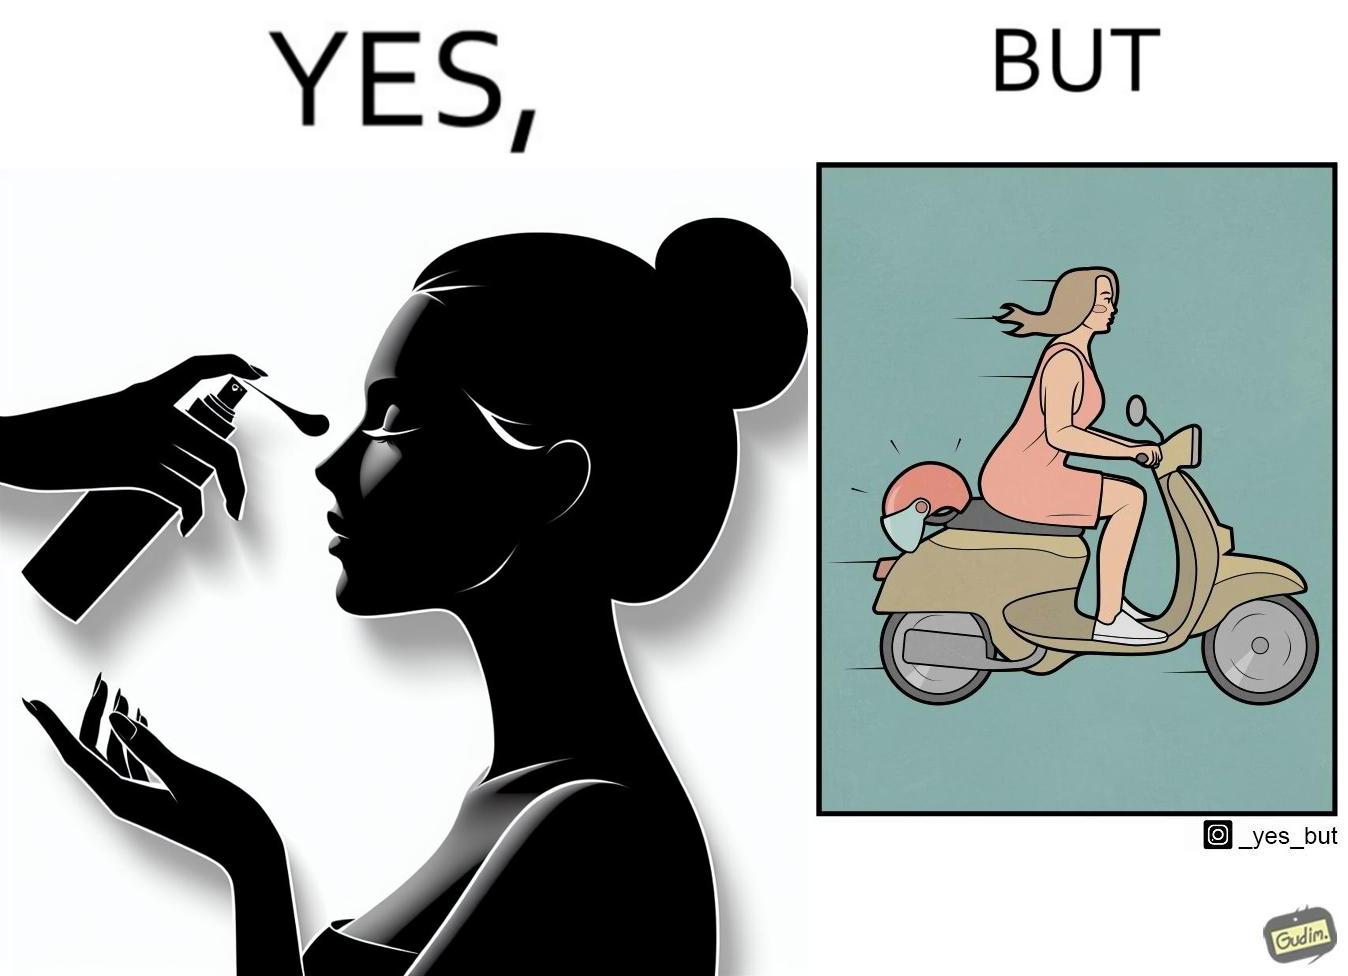Is this a satirical image? Yes, this image is satirical. 